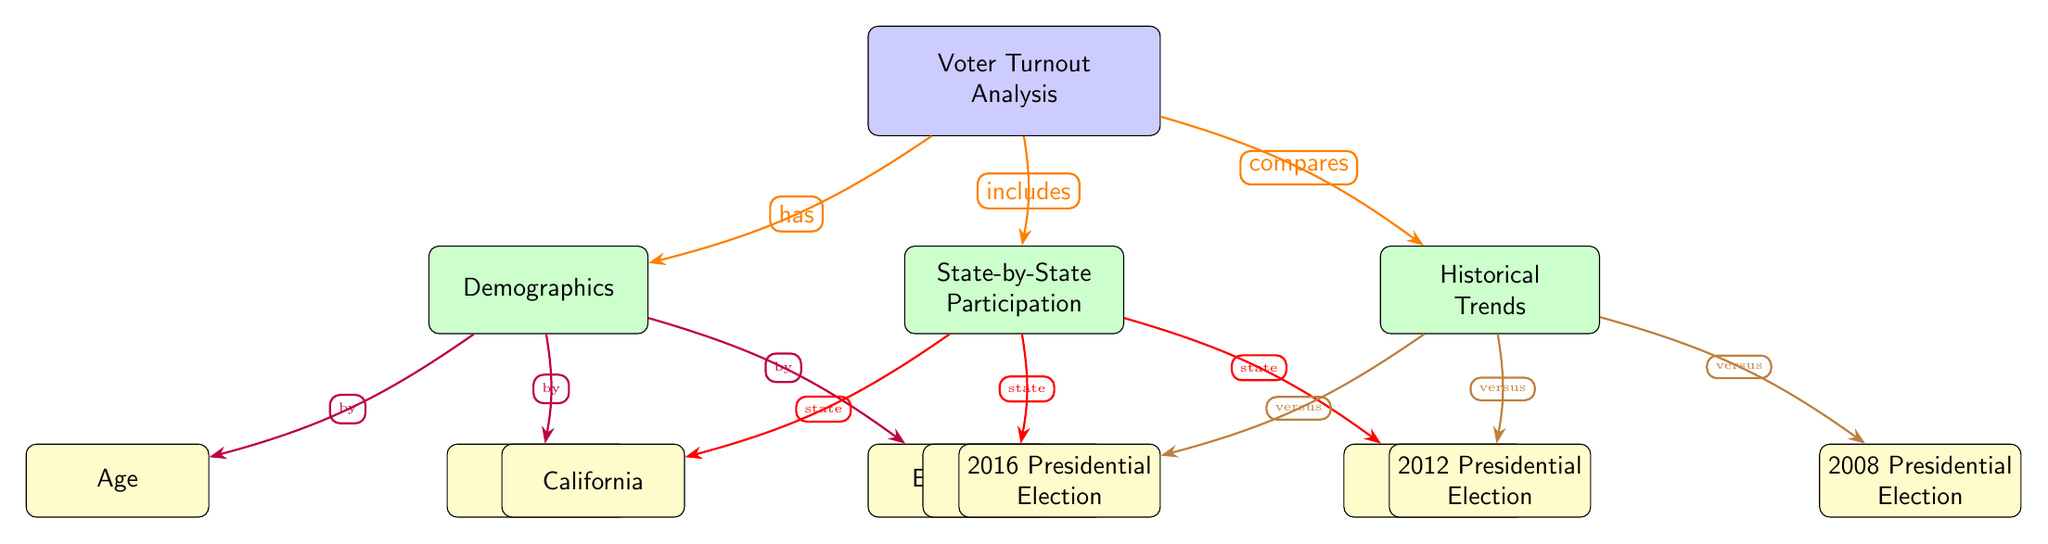What are the three main branches of voter turnout analysis? The diagram features three distinct branches stemming from the main node "Voter Turnout Analysis". These branches are "Demographics", "State-by-State Participation", and "Historical Trends".
Answer: Demographics, State-by-State Participation, Historical Trends How many demographic categories are represented in the diagram? Under the "Demographics" branch, there are three categories: "Age", "Gender", and "Ethnicity". Therefore, the total is three categories.
Answer: 3 Which state is listed as part of the state-by-state participation analysis? The diagram references three states under "State-by-State Participation": "California", "Texas", and "Florida". One of these states is "California".
Answer: California What is the relationship between voter turnout analysis and demographics? The arrow labeled "has" connects "Voter Turnout Analysis" to "Demographics", indicating that the analysis includes demographics as a component.
Answer: has Which historical presidential election is not a comparison point in the diagram? The diagram outlines the comparisons to the 2008, 2012, and 2016 presidential elections under the "Historical Trends" branch. Thus, the election not mentioned as a comparison is 2004.
Answer: 2004 How does the diagram categorize the demographic factors? The "Demographics" branch is divided into three subsections: "Age", "Gender", and "Ethnicity". Each subsection represents a specific aspect of demographics.
Answer: by age, gender, ethnicity What does the arrow from "State-by-State Participation" to "California" represent? In the diagram, the arrow is labeled "state", indicating a specific state (California) being analyzed as part of the overall state-by-state participation.
Answer: state 